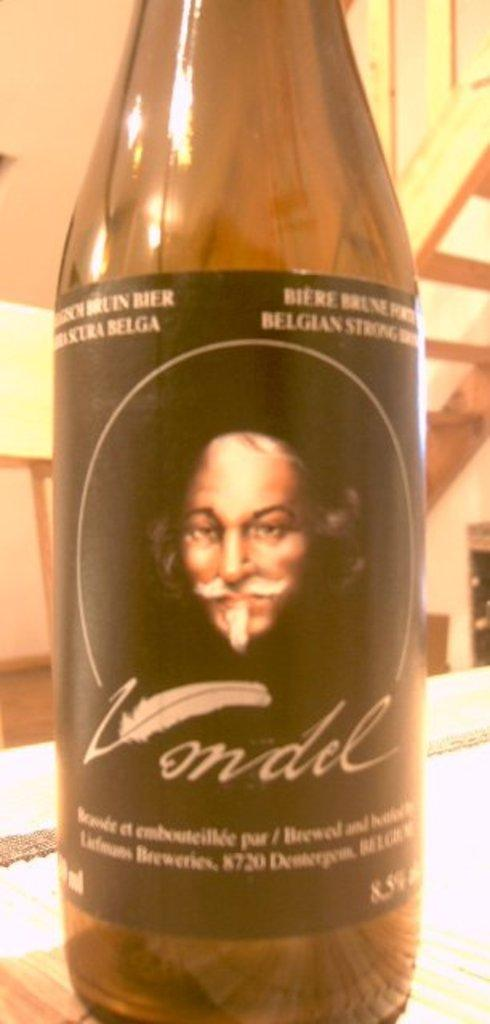<image>
Present a compact description of the photo's key features. a close up of a bottle of Londel beer on table 